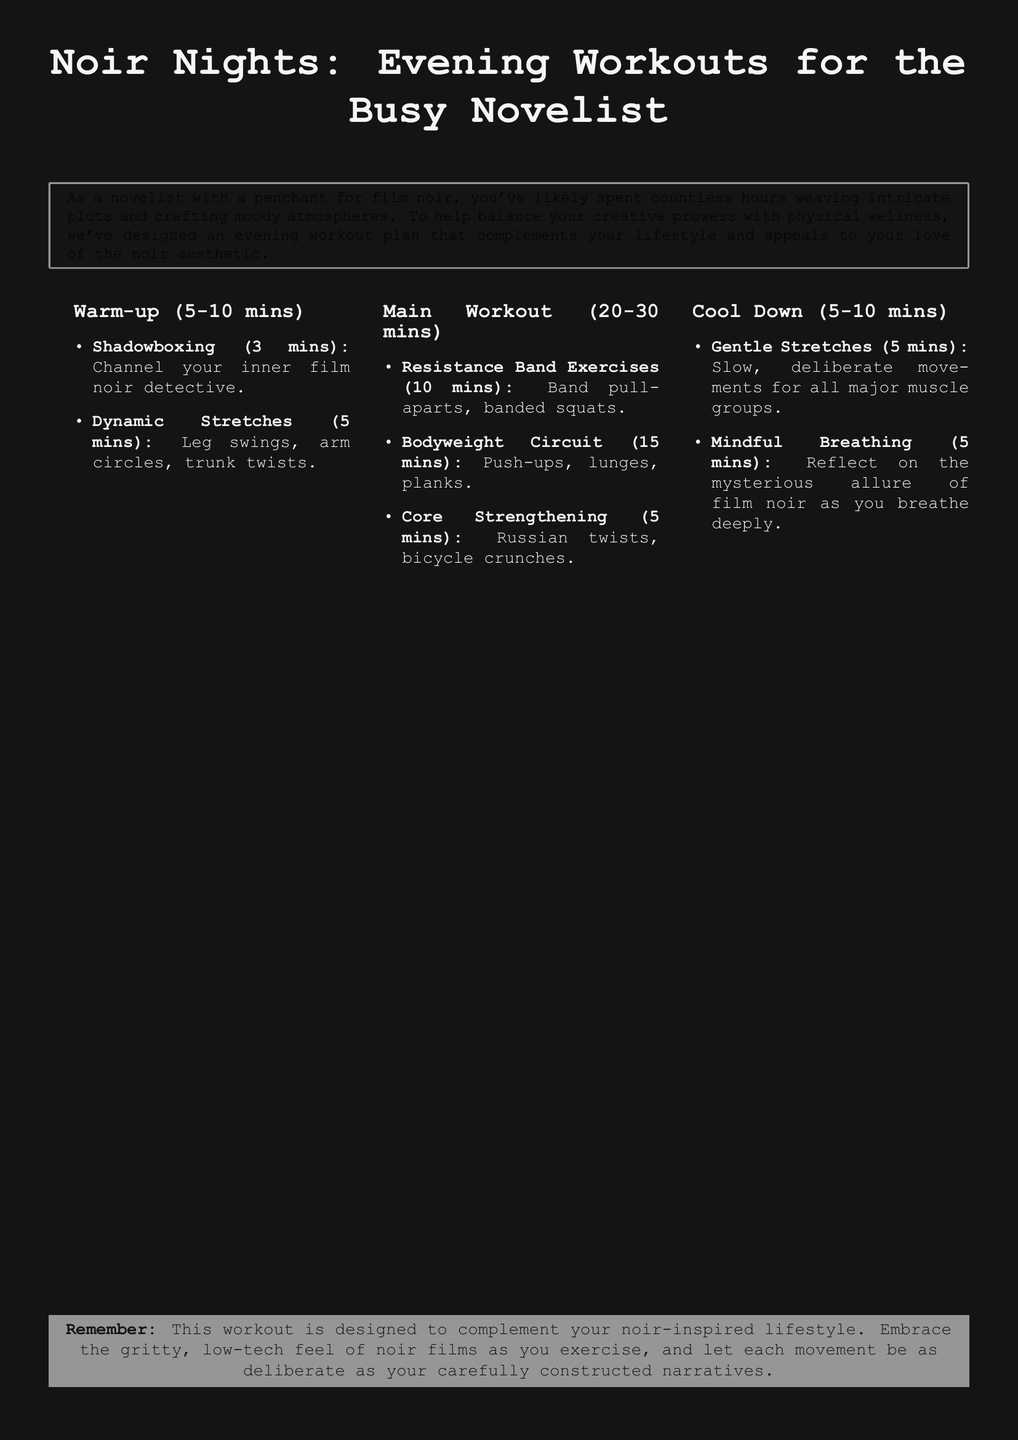What is the total duration of the warm-up? The warm-up duration is specified as 5-10 minutes in the document.
Answer: 5-10 minutes How long is the main workout? The main workout duration is given as 20-30 minutes in the document.
Answer: 20-30 minutes What is one type of exercise mentioned in the cool down? The cool down section lists gentle stretches among other activities.
Answer: Gentle stretches What is the first exercise listed in the warm-up? The first exercise in the warm-up is shadowboxing.
Answer: Shadowboxing How many minutes is allocated for core strengthening? The core strengthening section specifically states it is 5 minutes long.
Answer: 5 minutes What is emphasized during mindful breathing? The document emphasizes reflecting on the mysterious allure of film noir.
Answer: Reflect on the mysterious allure of film noir What type of exercises are included in the main workout? The main workout includes resistance band exercises, bodyweight circuit, and core strengthening.
Answer: Resistance band exercises What is the purpose of the workout plan? The purpose is to balance creative prowess with physical wellness.
Answer: Balance creative prowess with physical wellness What color is the background of the document? The background color of the document is noir black.
Answer: Noir black 